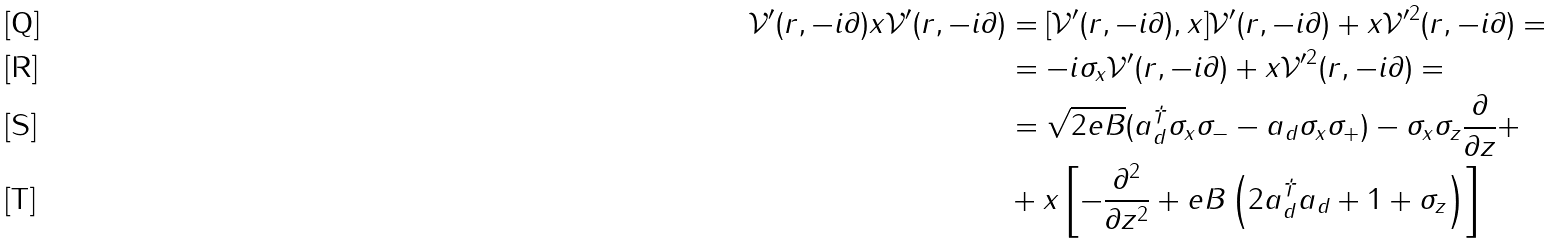Convert formula to latex. <formula><loc_0><loc_0><loc_500><loc_500>\mathcal { V } ^ { \prime } ( r , - i \partial ) x \mathcal { V } ^ { \prime } ( r , - i \partial ) & = [ \mathcal { V } ^ { \prime } ( r , - i \partial ) , x ] \mathcal { V } ^ { \prime } ( r , - i \partial ) + x \mathcal { V } ^ { \prime 2 } ( r , - i \partial ) = \\ & = - i \sigma _ { x } \mathcal { V } ^ { \prime } ( r , - i \partial ) + x \mathcal { V } ^ { \prime 2 } ( r , - i \partial ) = \\ & = \sqrt { 2 e B } ( a _ { d } ^ { \dag } \sigma _ { x } \sigma _ { - } - a _ { d } \sigma _ { x } \sigma _ { + } ) - \sigma _ { x } \sigma _ { z } \frac { \partial } { \partial z } + \\ & + x \left [ - \frac { \partial ^ { 2 } } { \partial z ^ { 2 } } + e B \left ( 2 a _ { d } ^ { \dag } a _ { d } + 1 + \sigma _ { z } \right ) \right ]</formula> 